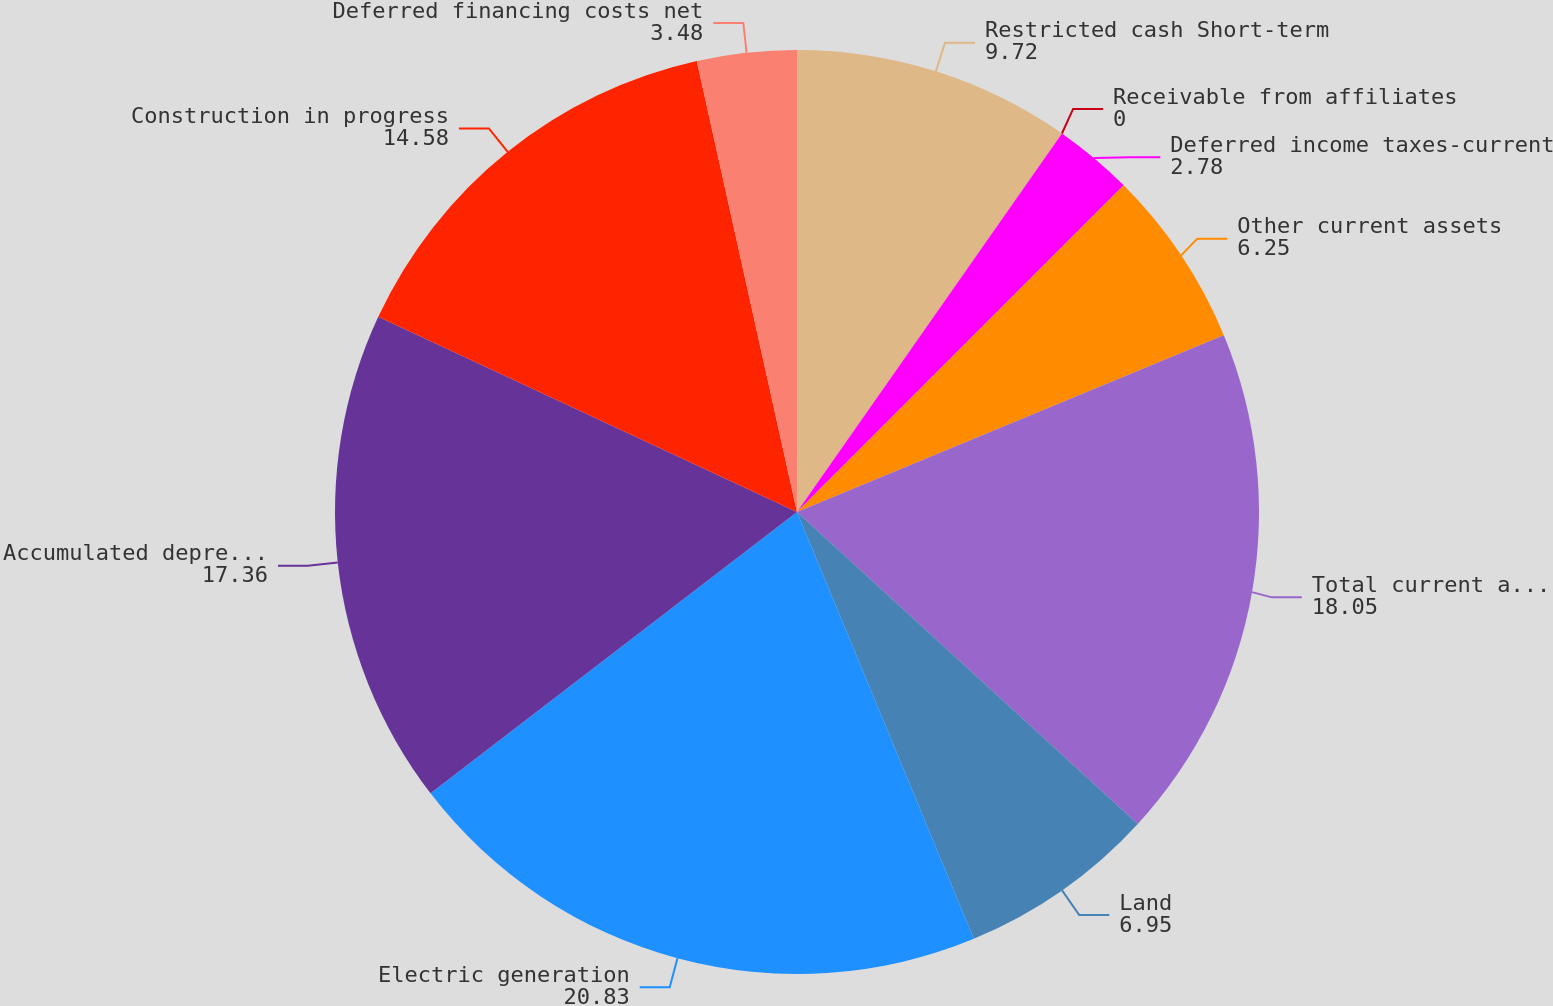<chart> <loc_0><loc_0><loc_500><loc_500><pie_chart><fcel>Restricted cash Short-term<fcel>Receivable from affiliates<fcel>Deferred income taxes-current<fcel>Other current assets<fcel>Total current assets<fcel>Land<fcel>Electric generation<fcel>Accumulated depreciation<fcel>Construction in progress<fcel>Deferred financing costs net<nl><fcel>9.72%<fcel>0.0%<fcel>2.78%<fcel>6.25%<fcel>18.05%<fcel>6.95%<fcel>20.83%<fcel>17.36%<fcel>14.58%<fcel>3.48%<nl></chart> 